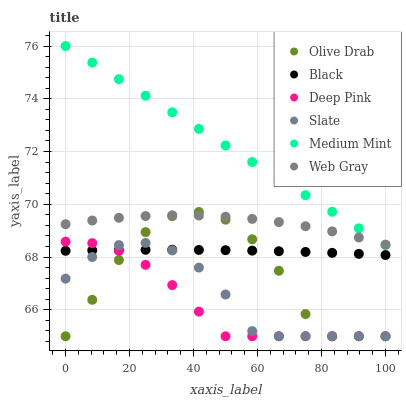Does Deep Pink have the minimum area under the curve?
Answer yes or no. Yes. Does Medium Mint have the maximum area under the curve?
Answer yes or no. Yes. Does Slate have the minimum area under the curve?
Answer yes or no. No. Does Slate have the maximum area under the curve?
Answer yes or no. No. Is Medium Mint the smoothest?
Answer yes or no. Yes. Is Olive Drab the roughest?
Answer yes or no. Yes. Is Deep Pink the smoothest?
Answer yes or no. No. Is Deep Pink the roughest?
Answer yes or no. No. Does Deep Pink have the lowest value?
Answer yes or no. Yes. Does Web Gray have the lowest value?
Answer yes or no. No. Does Medium Mint have the highest value?
Answer yes or no. Yes. Does Deep Pink have the highest value?
Answer yes or no. No. Is Slate less than Medium Mint?
Answer yes or no. Yes. Is Medium Mint greater than Slate?
Answer yes or no. Yes. Does Deep Pink intersect Olive Drab?
Answer yes or no. Yes. Is Deep Pink less than Olive Drab?
Answer yes or no. No. Is Deep Pink greater than Olive Drab?
Answer yes or no. No. Does Slate intersect Medium Mint?
Answer yes or no. No. 